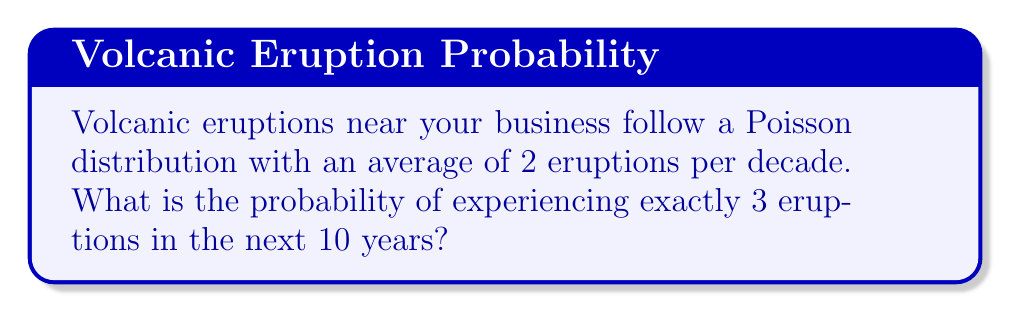Give your solution to this math problem. To solve this problem, we'll use the Poisson distribution formula:

$$P(X = k) = \frac{e^{-\lambda} \lambda^k}{k!}$$

Where:
- $\lambda$ is the average number of events in the given time period
- $k$ is the number of events we're calculating the probability for
- $e$ is Euler's number (approximately 2.71828)

Given:
- $\lambda = 2$ (average of 2 eruptions per decade)
- $k = 3$ (we want the probability of exactly 3 eruptions)

Steps:
1) Substitute the values into the formula:

   $$P(X = 3) = \frac{e^{-2} 2^3}{3!}$$

2) Calculate $2^3 = 8$

3) Calculate $3! = 3 \times 2 \times 1 = 6$

4) Simplify:

   $$P(X = 3) = \frac{e^{-2} \times 8}{6}$$

5) Calculate $e^{-2} \approx 0.1353$

6) Final calculation:

   $$P(X = 3) = \frac{0.1353 \times 8}{6} \approx 0.1804$$

Therefore, the probability of experiencing exactly 3 eruptions in the next 10 years is approximately 0.1804 or 18.04%.
Answer: 0.1804 (or 18.04%) 